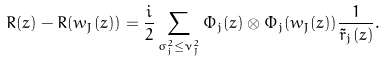<formula> <loc_0><loc_0><loc_500><loc_500>R ( z ) - R ( w _ { J } ( z ) ) = \frac { i } { 2 } \sum _ { \sigma _ { j } ^ { 2 } \leq \nu _ { J } ^ { 2 } } \Phi _ { j } ( z ) \otimes \Phi _ { j } ( w _ { J } ( z ) ) \frac { 1 } { \tilde { r } _ { j } ( z ) } .</formula> 